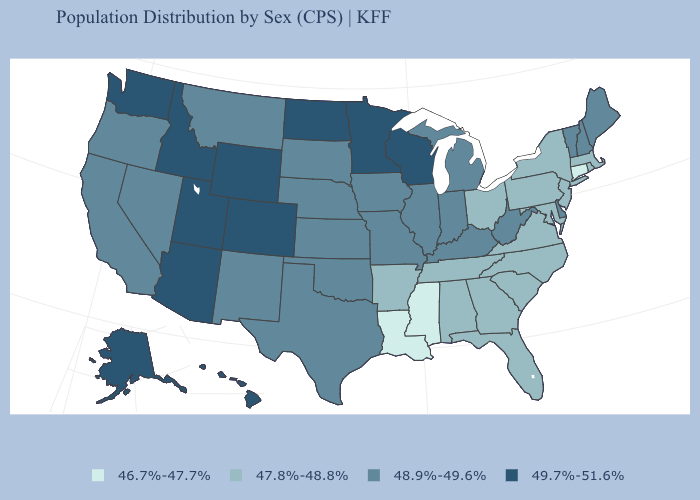Does California have the highest value in the West?
Answer briefly. No. What is the value of Louisiana?
Be succinct. 46.7%-47.7%. What is the value of Pennsylvania?
Short answer required. 47.8%-48.8%. Does Idaho have a higher value than New York?
Quick response, please. Yes. What is the value of Colorado?
Quick response, please. 49.7%-51.6%. Name the states that have a value in the range 47.8%-48.8%?
Keep it brief. Alabama, Arkansas, Florida, Georgia, Maryland, Massachusetts, New Jersey, New York, North Carolina, Ohio, Pennsylvania, Rhode Island, South Carolina, Tennessee, Virginia. What is the value of Minnesota?
Concise answer only. 49.7%-51.6%. What is the highest value in the USA?
Short answer required. 49.7%-51.6%. What is the value of Minnesota?
Short answer required. 49.7%-51.6%. What is the value of Colorado?
Keep it brief. 49.7%-51.6%. Name the states that have a value in the range 47.8%-48.8%?
Short answer required. Alabama, Arkansas, Florida, Georgia, Maryland, Massachusetts, New Jersey, New York, North Carolina, Ohio, Pennsylvania, Rhode Island, South Carolina, Tennessee, Virginia. Does Connecticut have the lowest value in the Northeast?
Write a very short answer. Yes. What is the lowest value in the MidWest?
Short answer required. 47.8%-48.8%. Which states hav the highest value in the MidWest?
Answer briefly. Minnesota, North Dakota, Wisconsin. What is the highest value in states that border South Carolina?
Short answer required. 47.8%-48.8%. 